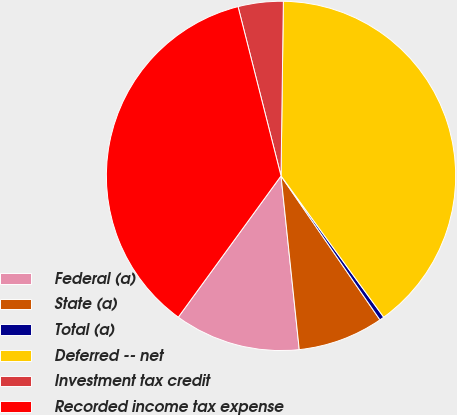<chart> <loc_0><loc_0><loc_500><loc_500><pie_chart><fcel>Federal (a)<fcel>State (a)<fcel>Total (a)<fcel>Deferred -- net<fcel>Investment tax credit<fcel>Recorded income tax expense<nl><fcel>11.67%<fcel>7.92%<fcel>0.42%<fcel>39.78%<fcel>4.17%<fcel>36.03%<nl></chart> 